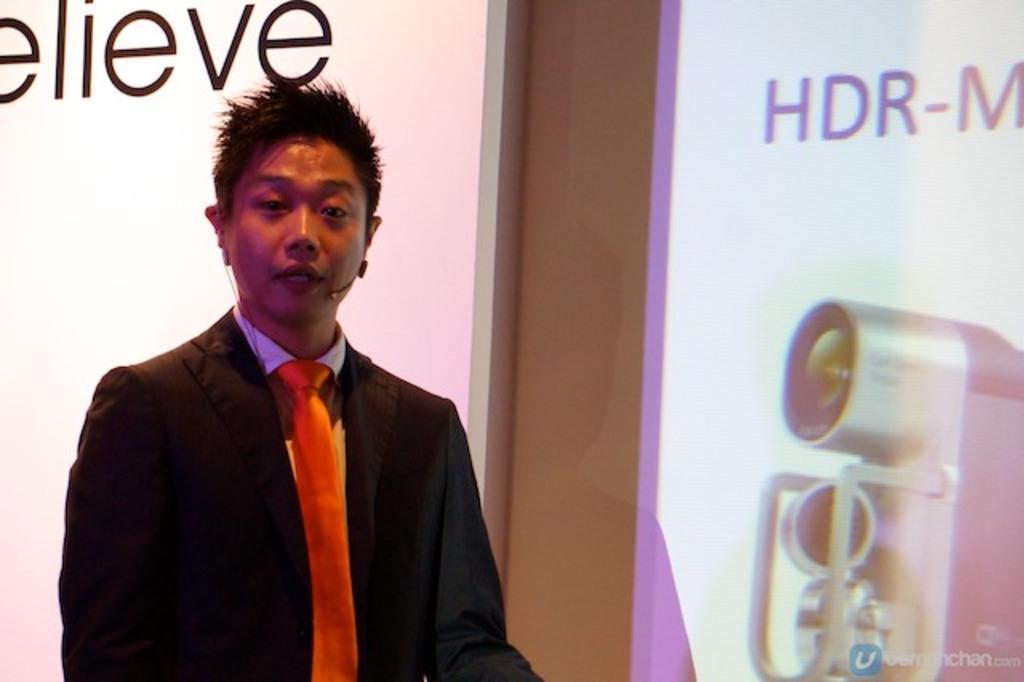Describe this image in one or two sentences. There is a guy standing on the floor having a microphone speaking to someone. He is wearing a coat, shirt and a tie. Behind this guy, there is a screen on which something is written. To the right of this guy, there looks like a camera with some lens and on that screen we can see that HDR. 